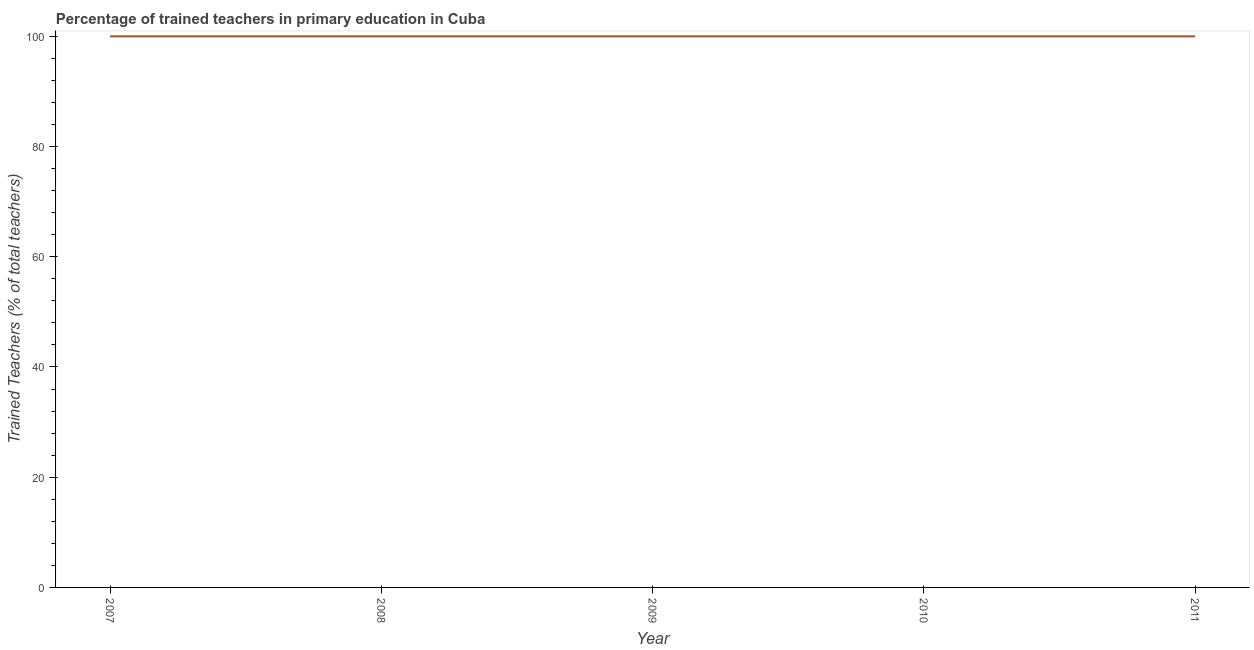What is the percentage of trained teachers in 2009?
Your answer should be compact. 100. Across all years, what is the maximum percentage of trained teachers?
Your answer should be very brief. 100. Across all years, what is the minimum percentage of trained teachers?
Provide a succinct answer. 100. In which year was the percentage of trained teachers maximum?
Offer a terse response. 2007. What is the sum of the percentage of trained teachers?
Keep it short and to the point. 500. What is the average percentage of trained teachers per year?
Ensure brevity in your answer.  100. What is the median percentage of trained teachers?
Give a very brief answer. 100. Is the percentage of trained teachers in 2009 less than that in 2011?
Give a very brief answer. No. Is the difference between the percentage of trained teachers in 2007 and 2008 greater than the difference between any two years?
Your response must be concise. Yes. What is the difference between the highest and the second highest percentage of trained teachers?
Make the answer very short. 0. Is the sum of the percentage of trained teachers in 2007 and 2008 greater than the maximum percentage of trained teachers across all years?
Your response must be concise. Yes. In how many years, is the percentage of trained teachers greater than the average percentage of trained teachers taken over all years?
Offer a terse response. 0. How many years are there in the graph?
Your answer should be compact. 5. What is the difference between two consecutive major ticks on the Y-axis?
Make the answer very short. 20. Are the values on the major ticks of Y-axis written in scientific E-notation?
Make the answer very short. No. Does the graph contain any zero values?
Offer a very short reply. No. What is the title of the graph?
Give a very brief answer. Percentage of trained teachers in primary education in Cuba. What is the label or title of the X-axis?
Your response must be concise. Year. What is the label or title of the Y-axis?
Your answer should be compact. Trained Teachers (% of total teachers). What is the Trained Teachers (% of total teachers) of 2008?
Offer a very short reply. 100. What is the Trained Teachers (% of total teachers) in 2011?
Your answer should be compact. 100. What is the difference between the Trained Teachers (% of total teachers) in 2007 and 2008?
Keep it short and to the point. 0. What is the difference between the Trained Teachers (% of total teachers) in 2007 and 2009?
Your answer should be compact. 0. What is the difference between the Trained Teachers (% of total teachers) in 2007 and 2010?
Offer a very short reply. 0. What is the difference between the Trained Teachers (% of total teachers) in 2008 and 2009?
Give a very brief answer. 0. What is the difference between the Trained Teachers (% of total teachers) in 2008 and 2011?
Offer a very short reply. 0. What is the difference between the Trained Teachers (% of total teachers) in 2009 and 2010?
Offer a terse response. 0. What is the difference between the Trained Teachers (% of total teachers) in 2009 and 2011?
Keep it short and to the point. 0. What is the ratio of the Trained Teachers (% of total teachers) in 2008 to that in 2011?
Your answer should be compact. 1. What is the ratio of the Trained Teachers (% of total teachers) in 2009 to that in 2010?
Your answer should be compact. 1. What is the ratio of the Trained Teachers (% of total teachers) in 2009 to that in 2011?
Keep it short and to the point. 1. 